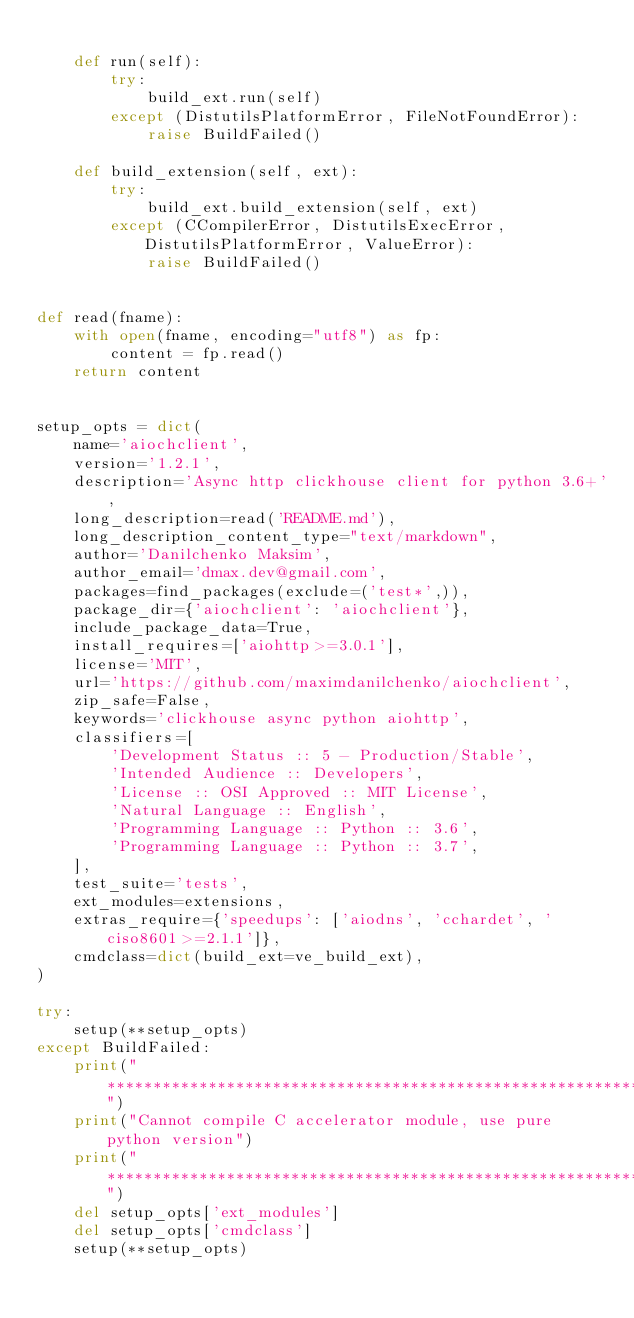Convert code to text. <code><loc_0><loc_0><loc_500><loc_500><_Python_>
    def run(self):
        try:
            build_ext.run(self)
        except (DistutilsPlatformError, FileNotFoundError):
            raise BuildFailed()

    def build_extension(self, ext):
        try:
            build_ext.build_extension(self, ext)
        except (CCompilerError, DistutilsExecError, DistutilsPlatformError, ValueError):
            raise BuildFailed()


def read(fname):
    with open(fname, encoding="utf8") as fp:
        content = fp.read()
    return content


setup_opts = dict(
    name='aiochclient',
    version='1.2.1',
    description='Async http clickhouse client for python 3.6+',
    long_description=read('README.md'),
    long_description_content_type="text/markdown",
    author='Danilchenko Maksim',
    author_email='dmax.dev@gmail.com',
    packages=find_packages(exclude=('test*',)),
    package_dir={'aiochclient': 'aiochclient'},
    include_package_data=True,
    install_requires=['aiohttp>=3.0.1'],
    license='MIT',
    url='https://github.com/maximdanilchenko/aiochclient',
    zip_safe=False,
    keywords='clickhouse async python aiohttp',
    classifiers=[
        'Development Status :: 5 - Production/Stable',
        'Intended Audience :: Developers',
        'License :: OSI Approved :: MIT License',
        'Natural Language :: English',
        'Programming Language :: Python :: 3.6',
        'Programming Language :: Python :: 3.7',
    ],
    test_suite='tests',
    ext_modules=extensions,
    extras_require={'speedups': ['aiodns', 'cchardet', 'ciso8601>=2.1.1']},
    cmdclass=dict(build_ext=ve_build_ext),
)

try:
    setup(**setup_opts)
except BuildFailed:
    print("************************************************************")
    print("Cannot compile C accelerator module, use pure python version")
    print("************************************************************")
    del setup_opts['ext_modules']
    del setup_opts['cmdclass']
    setup(**setup_opts)
</code> 